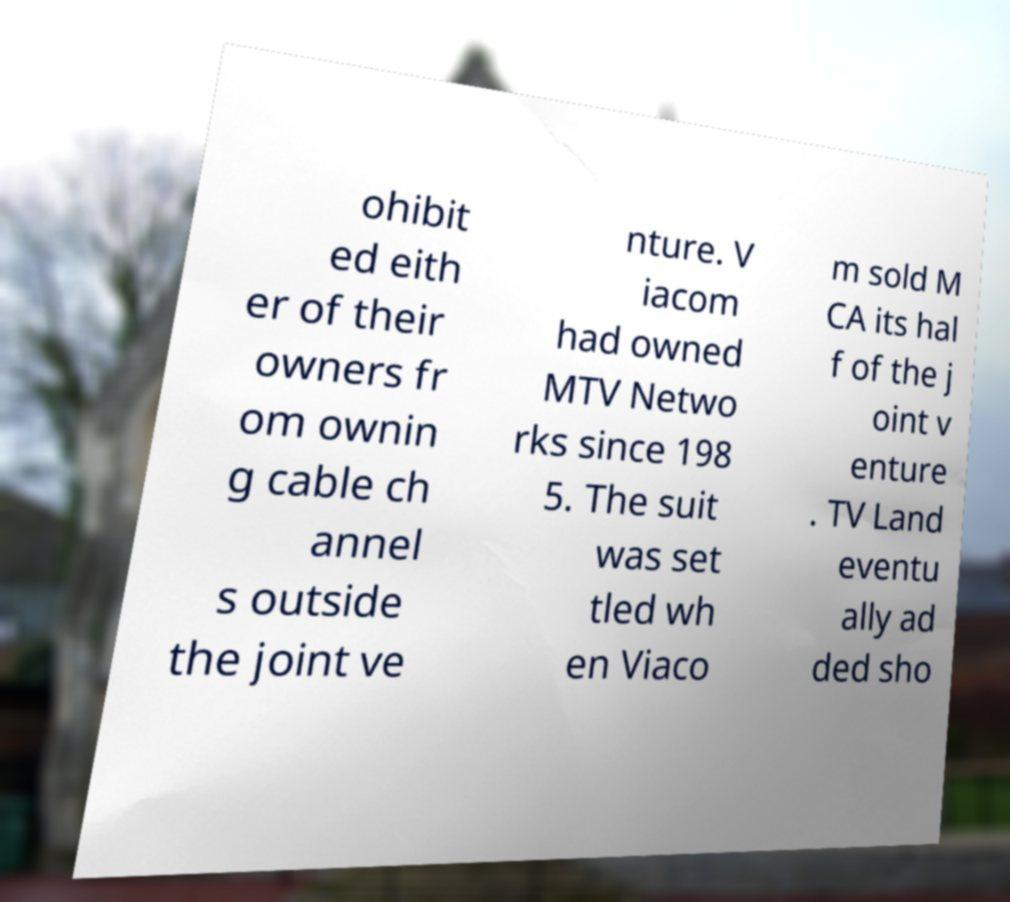Can you read and provide the text displayed in the image?This photo seems to have some interesting text. Can you extract and type it out for me? ohibit ed eith er of their owners fr om ownin g cable ch annel s outside the joint ve nture. V iacom had owned MTV Netwo rks since 198 5. The suit was set tled wh en Viaco m sold M CA its hal f of the j oint v enture . TV Land eventu ally ad ded sho 